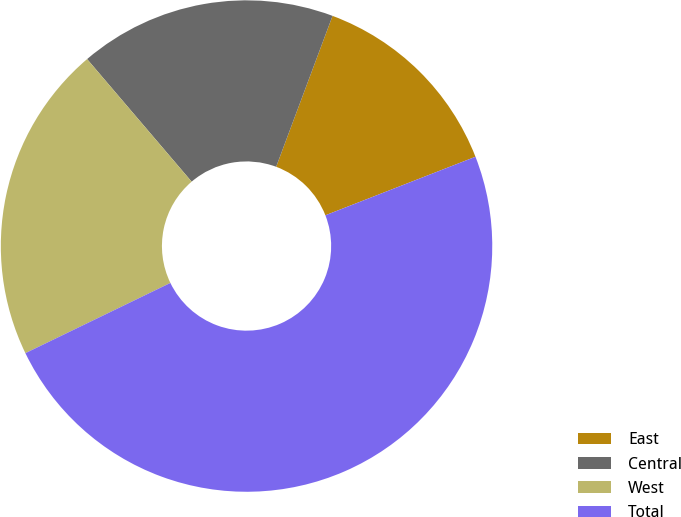<chart> <loc_0><loc_0><loc_500><loc_500><pie_chart><fcel>East<fcel>Central<fcel>West<fcel>Total<nl><fcel>13.39%<fcel>16.93%<fcel>20.94%<fcel>48.74%<nl></chart> 